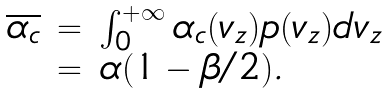<formula> <loc_0><loc_0><loc_500><loc_500>\begin{array} { l l l } \overline { \alpha _ { c } } & = & \int _ { 0 } ^ { + \infty } \alpha _ { c } ( v _ { z } ) p ( v _ { z } ) d v _ { z } \\ & = & \alpha ( 1 - \beta / 2 ) . \end{array}</formula> 